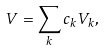Convert formula to latex. <formula><loc_0><loc_0><loc_500><loc_500>V = \sum _ { k } c _ { k } V _ { k } ,</formula> 